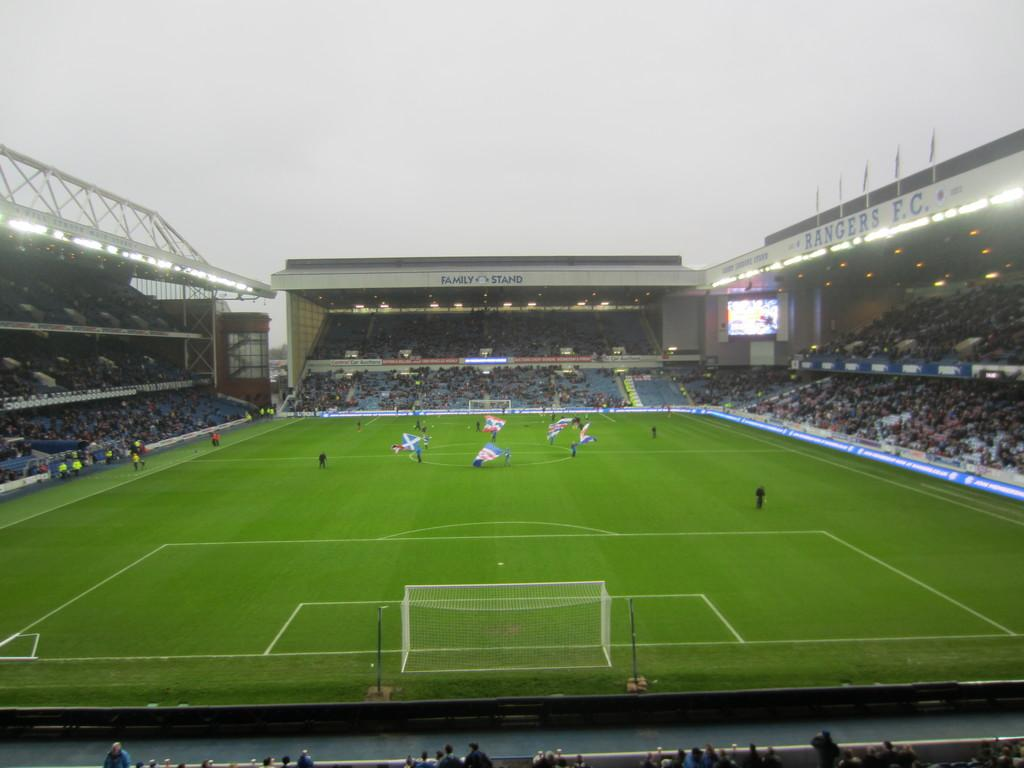<image>
Offer a succinct explanation of the picture presented. The Rangers F.C.soccer field with people playing and fans watching 